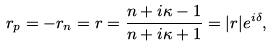Convert formula to latex. <formula><loc_0><loc_0><loc_500><loc_500>r _ { p } = - r _ { n } = r = \frac { n + i \kappa - 1 } { n + i \kappa + 1 } = | r | e ^ { i \delta } ,</formula> 